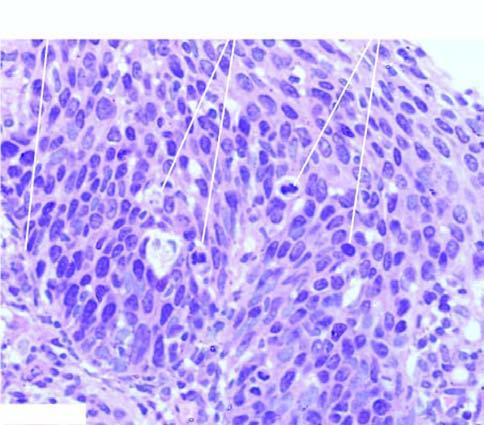re removal of suture confined to all the layers of the mucosa but the basement membrane on which these layers rest is intact?
Answer the question using a single word or phrase. No 